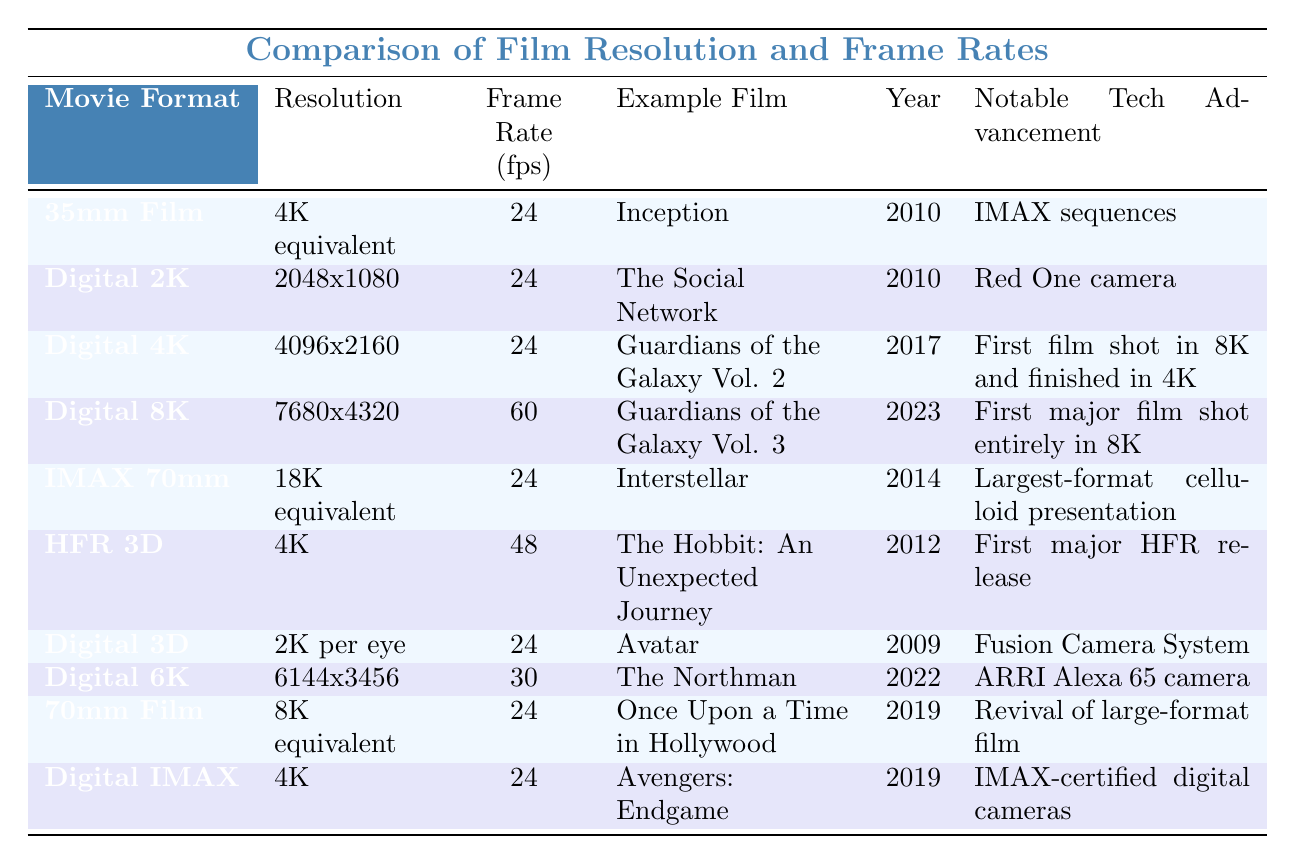What is the frame rate for "Guardians of the Galaxy Vol. 2"? The table lists the frame rates for each movie. For "Guardians of the Galaxy Vol. 2," the frame rate is recorded as 24 fps.
Answer: 24 fps Which movie format has the highest resolution listed? By reviewing the 'Resolution' column, the highest resolution is 7680x4320, which is associated with the "Digital 8K" format.
Answer: Digital 8K True or False: "Avatar" was released in 2012. The table shows that "Avatar" was released in 2009, which confirms that the statement is false.
Answer: False What is the difference in frame rates between "Digital 8K" and "HFR 3D"? "Digital 8K" has a frame rate of 60 fps, while "HFR 3D" has a frame rate of 48 fps. The difference is calculated as 60 - 48 = 12 fps.
Answer: 12 fps How many movies listed have a frame rate of 24 fps? Reviewing the table, the movies with a frame rate of 24 fps include "Inception," "The Social Network," "Guardians of the Galaxy Vol. 2," "Interstellar," "70mm Film," and "Digital IMAX," totaling 6 movies.
Answer: 6 movies Which notable tech advancement is associated with "Guardians of the Galaxy Vol. 3"? Looking under the "Notable Tech Advancement" column for "Guardians of the Galaxy Vol. 3," the entry states it was the "First major film shot entirely in 8K."
Answer: First major film shot entirely in 8K Compare the resolution of "Digital 2K" to "Digital 6K". What is the ratio of "Digital 2K" resolution to "Digital 6K"? "Digital 2K" has a resolution of 2048x1080 and "Digital 6K" has a resolution of 6144x3456. To find the ratio, divide both resolutions: (2048x1080) / (6144x3456) simplifies to 1/3.
Answer: 1:3 In what year was "The Hobbit: An Unexpected Journey" released and how does its frame rate compare to "Avatar"? "The Hobbit: An Unexpected Journey" was released in 2012 with a frame rate of 48 fps, while "Avatar," released in 2009, has a frame rate of 24 fps. The comparison shows "The Hobbit" has a higher frame rate.
Answer: 2012, higher frame rate What is the resolution format of "IMAX 70mm" compared to "70mm Film"? "IMAX 70mm" is listed as having an "18K equivalent" resolution, while "70mm Film" is marked as "8K equivalent." This shows that "IMAX 70mm" has a higher resolution format than "70mm Film."
Answer: IMAX 70mm has a higher resolution 